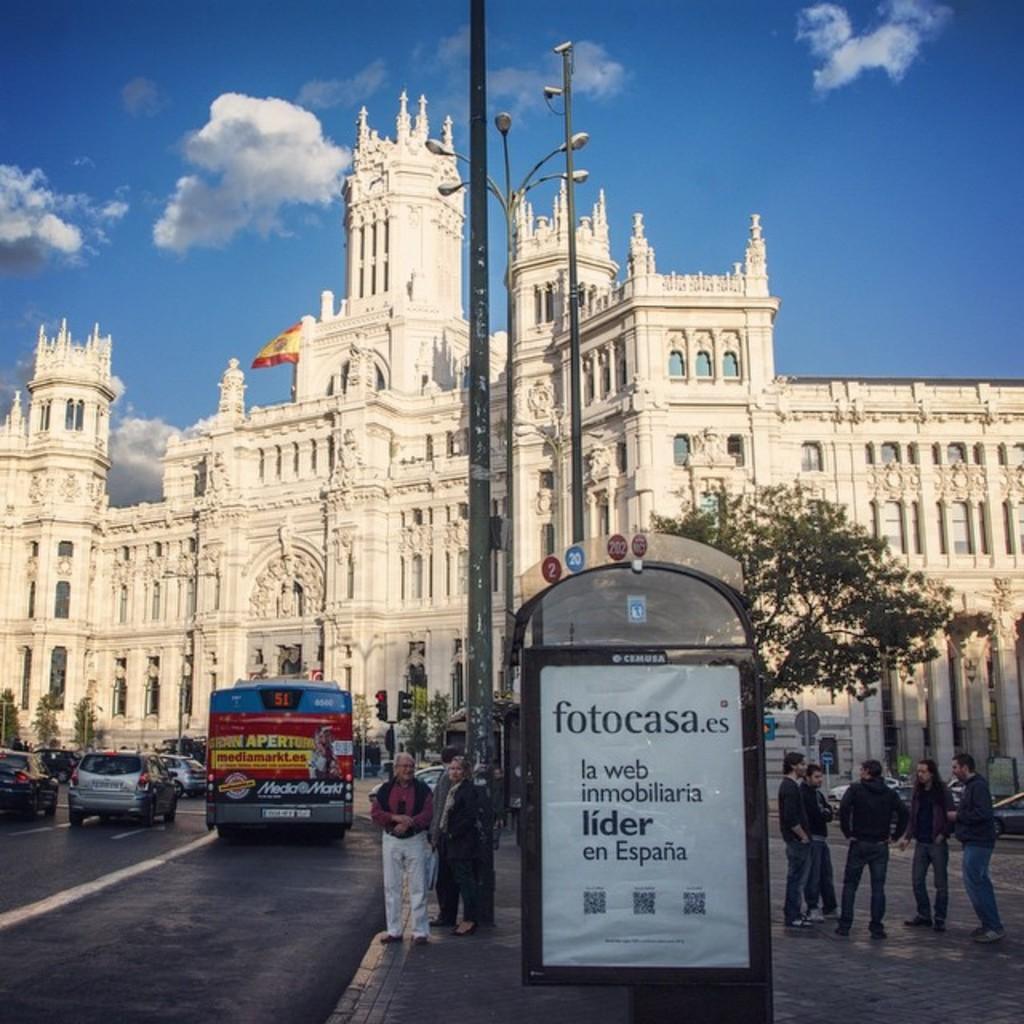Describe this image in one or two sentences. In this picture there are group of people those who are standing on the right side of the image and there is a poster in the center of the image, there are poles in the center of the image, there is a palace in the background area of the image and there are cars and a bus on the left side of the image, there are other people in the center of the image. 